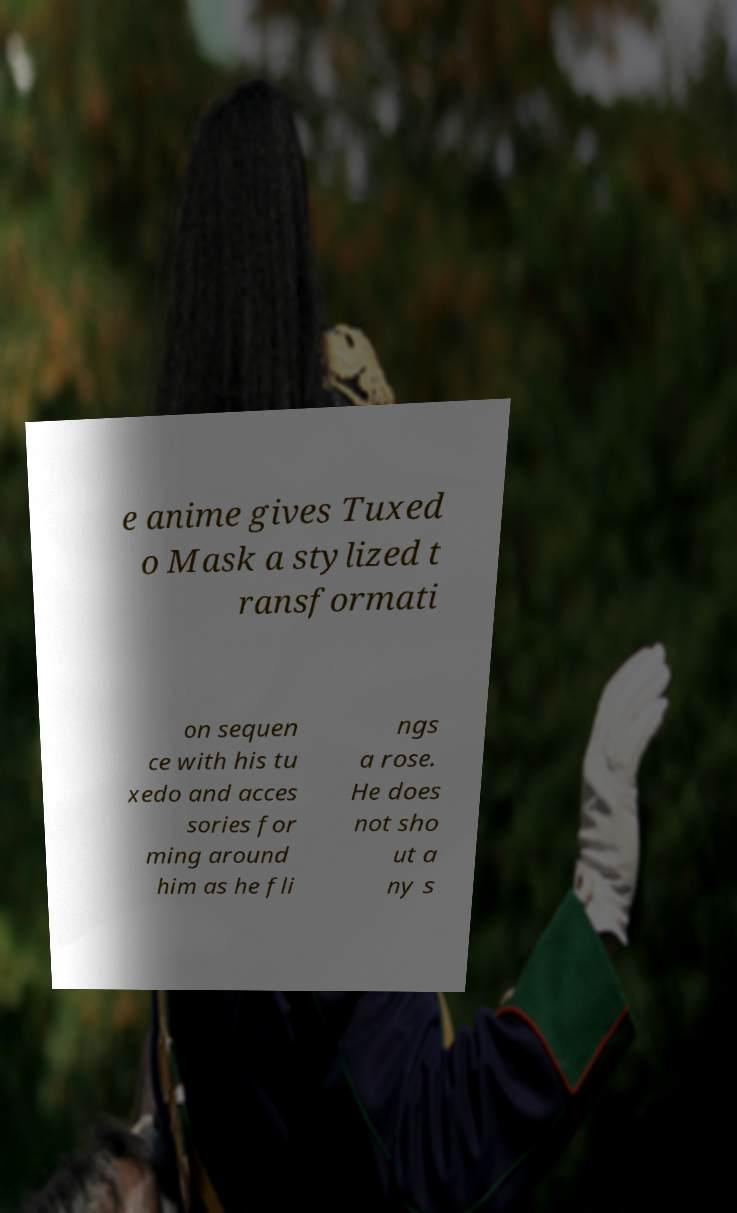Please read and relay the text visible in this image. What does it say? e anime gives Tuxed o Mask a stylized t ransformati on sequen ce with his tu xedo and acces sories for ming around him as he fli ngs a rose. He does not sho ut a ny s 